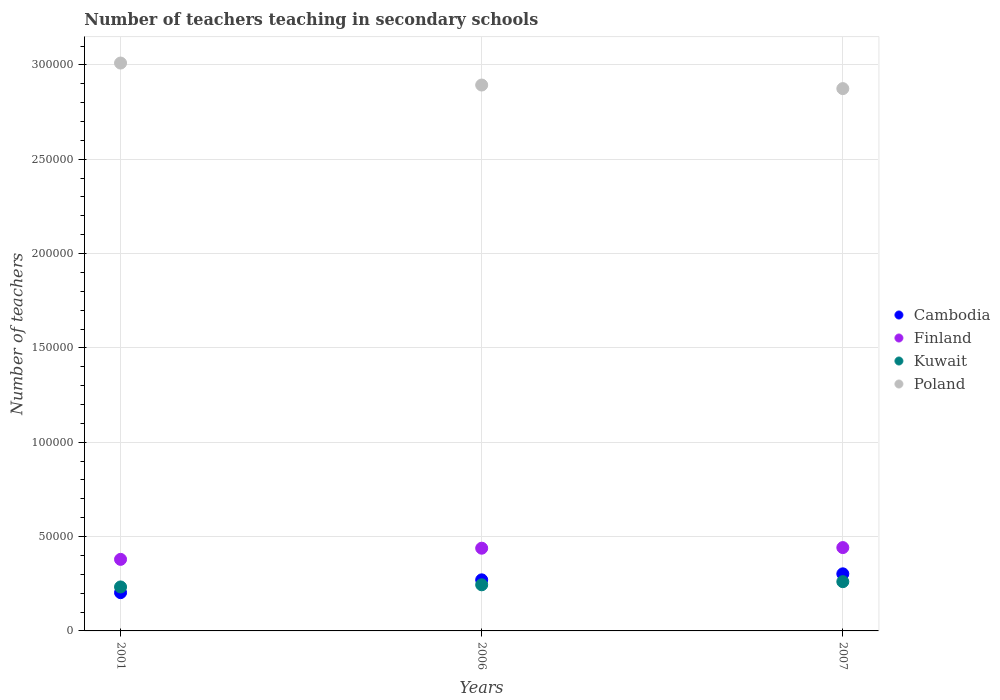What is the number of teachers teaching in secondary schools in Poland in 2007?
Give a very brief answer. 2.87e+05. Across all years, what is the maximum number of teachers teaching in secondary schools in Kuwait?
Your answer should be compact. 2.61e+04. Across all years, what is the minimum number of teachers teaching in secondary schools in Cambodia?
Provide a succinct answer. 2.03e+04. In which year was the number of teachers teaching in secondary schools in Poland maximum?
Provide a succinct answer. 2001. In which year was the number of teachers teaching in secondary schools in Finland minimum?
Offer a terse response. 2001. What is the total number of teachers teaching in secondary schools in Cambodia in the graph?
Provide a succinct answer. 7.76e+04. What is the difference between the number of teachers teaching in secondary schools in Cambodia in 2001 and that in 2007?
Provide a short and direct response. -9972. What is the difference between the number of teachers teaching in secondary schools in Poland in 2006 and the number of teachers teaching in secondary schools in Finland in 2001?
Provide a short and direct response. 2.51e+05. What is the average number of teachers teaching in secondary schools in Finland per year?
Ensure brevity in your answer.  4.20e+04. In the year 2007, what is the difference between the number of teachers teaching in secondary schools in Kuwait and number of teachers teaching in secondary schools in Finland?
Make the answer very short. -1.81e+04. In how many years, is the number of teachers teaching in secondary schools in Poland greater than 280000?
Your answer should be very brief. 3. What is the ratio of the number of teachers teaching in secondary schools in Cambodia in 2001 to that in 2006?
Your answer should be very brief. 0.75. Is the number of teachers teaching in secondary schools in Finland in 2001 less than that in 2007?
Give a very brief answer. Yes. Is the difference between the number of teachers teaching in secondary schools in Kuwait in 2001 and 2007 greater than the difference between the number of teachers teaching in secondary schools in Finland in 2001 and 2007?
Keep it short and to the point. Yes. What is the difference between the highest and the second highest number of teachers teaching in secondary schools in Kuwait?
Your answer should be compact. 1658. What is the difference between the highest and the lowest number of teachers teaching in secondary schools in Kuwait?
Your answer should be compact. 2789. In how many years, is the number of teachers teaching in secondary schools in Kuwait greater than the average number of teachers teaching in secondary schools in Kuwait taken over all years?
Keep it short and to the point. 1. How many dotlines are there?
Your answer should be compact. 4. What is the difference between two consecutive major ticks on the Y-axis?
Provide a short and direct response. 5.00e+04. Are the values on the major ticks of Y-axis written in scientific E-notation?
Make the answer very short. No. Does the graph contain any zero values?
Provide a succinct answer. No. Does the graph contain grids?
Give a very brief answer. Yes. What is the title of the graph?
Offer a terse response. Number of teachers teaching in secondary schools. Does "Faeroe Islands" appear as one of the legend labels in the graph?
Offer a very short reply. No. What is the label or title of the X-axis?
Provide a short and direct response. Years. What is the label or title of the Y-axis?
Give a very brief answer. Number of teachers. What is the Number of teachers of Cambodia in 2001?
Your answer should be compact. 2.03e+04. What is the Number of teachers in Finland in 2001?
Keep it short and to the point. 3.79e+04. What is the Number of teachers in Kuwait in 2001?
Offer a terse response. 2.33e+04. What is the Number of teachers of Poland in 2001?
Keep it short and to the point. 3.01e+05. What is the Number of teachers in Cambodia in 2006?
Your answer should be very brief. 2.71e+04. What is the Number of teachers in Finland in 2006?
Provide a short and direct response. 4.38e+04. What is the Number of teachers in Kuwait in 2006?
Offer a very short reply. 2.44e+04. What is the Number of teachers in Poland in 2006?
Provide a succinct answer. 2.89e+05. What is the Number of teachers in Cambodia in 2007?
Provide a succinct answer. 3.03e+04. What is the Number of teachers of Finland in 2007?
Your response must be concise. 4.42e+04. What is the Number of teachers in Kuwait in 2007?
Give a very brief answer. 2.61e+04. What is the Number of teachers in Poland in 2007?
Offer a very short reply. 2.87e+05. Across all years, what is the maximum Number of teachers of Cambodia?
Your answer should be compact. 3.03e+04. Across all years, what is the maximum Number of teachers of Finland?
Offer a terse response. 4.42e+04. Across all years, what is the maximum Number of teachers in Kuwait?
Your answer should be compact. 2.61e+04. Across all years, what is the maximum Number of teachers of Poland?
Offer a terse response. 3.01e+05. Across all years, what is the minimum Number of teachers in Cambodia?
Keep it short and to the point. 2.03e+04. Across all years, what is the minimum Number of teachers of Finland?
Your answer should be very brief. 3.79e+04. Across all years, what is the minimum Number of teachers in Kuwait?
Give a very brief answer. 2.33e+04. Across all years, what is the minimum Number of teachers of Poland?
Give a very brief answer. 2.87e+05. What is the total Number of teachers in Cambodia in the graph?
Offer a very short reply. 7.76e+04. What is the total Number of teachers of Finland in the graph?
Your response must be concise. 1.26e+05. What is the total Number of teachers in Kuwait in the graph?
Give a very brief answer. 7.39e+04. What is the total Number of teachers of Poland in the graph?
Your answer should be very brief. 8.78e+05. What is the difference between the Number of teachers in Cambodia in 2001 and that in 2006?
Make the answer very short. -6784. What is the difference between the Number of teachers in Finland in 2001 and that in 2006?
Keep it short and to the point. -5915. What is the difference between the Number of teachers of Kuwait in 2001 and that in 2006?
Your answer should be very brief. -1131. What is the difference between the Number of teachers of Poland in 2001 and that in 2006?
Provide a succinct answer. 1.16e+04. What is the difference between the Number of teachers in Cambodia in 2001 and that in 2007?
Provide a succinct answer. -9972. What is the difference between the Number of teachers in Finland in 2001 and that in 2007?
Provide a succinct answer. -6245. What is the difference between the Number of teachers of Kuwait in 2001 and that in 2007?
Provide a succinct answer. -2789. What is the difference between the Number of teachers of Poland in 2001 and that in 2007?
Your answer should be compact. 1.35e+04. What is the difference between the Number of teachers in Cambodia in 2006 and that in 2007?
Provide a succinct answer. -3188. What is the difference between the Number of teachers of Finland in 2006 and that in 2007?
Your answer should be very brief. -330. What is the difference between the Number of teachers of Kuwait in 2006 and that in 2007?
Ensure brevity in your answer.  -1658. What is the difference between the Number of teachers in Poland in 2006 and that in 2007?
Offer a terse response. 1899. What is the difference between the Number of teachers in Cambodia in 2001 and the Number of teachers in Finland in 2006?
Keep it short and to the point. -2.36e+04. What is the difference between the Number of teachers in Cambodia in 2001 and the Number of teachers in Kuwait in 2006?
Your answer should be very brief. -4156. What is the difference between the Number of teachers of Cambodia in 2001 and the Number of teachers of Poland in 2006?
Provide a short and direct response. -2.69e+05. What is the difference between the Number of teachers of Finland in 2001 and the Number of teachers of Kuwait in 2006?
Give a very brief answer. 1.35e+04. What is the difference between the Number of teachers of Finland in 2001 and the Number of teachers of Poland in 2006?
Provide a succinct answer. -2.51e+05. What is the difference between the Number of teachers in Kuwait in 2001 and the Number of teachers in Poland in 2006?
Offer a very short reply. -2.66e+05. What is the difference between the Number of teachers of Cambodia in 2001 and the Number of teachers of Finland in 2007?
Provide a short and direct response. -2.39e+04. What is the difference between the Number of teachers in Cambodia in 2001 and the Number of teachers in Kuwait in 2007?
Provide a succinct answer. -5814. What is the difference between the Number of teachers in Cambodia in 2001 and the Number of teachers in Poland in 2007?
Offer a very short reply. -2.67e+05. What is the difference between the Number of teachers of Finland in 2001 and the Number of teachers of Kuwait in 2007?
Give a very brief answer. 1.18e+04. What is the difference between the Number of teachers of Finland in 2001 and the Number of teachers of Poland in 2007?
Your answer should be compact. -2.50e+05. What is the difference between the Number of teachers of Kuwait in 2001 and the Number of teachers of Poland in 2007?
Provide a short and direct response. -2.64e+05. What is the difference between the Number of teachers in Cambodia in 2006 and the Number of teachers in Finland in 2007?
Keep it short and to the point. -1.71e+04. What is the difference between the Number of teachers of Cambodia in 2006 and the Number of teachers of Kuwait in 2007?
Your response must be concise. 970. What is the difference between the Number of teachers of Cambodia in 2006 and the Number of teachers of Poland in 2007?
Give a very brief answer. -2.60e+05. What is the difference between the Number of teachers in Finland in 2006 and the Number of teachers in Kuwait in 2007?
Give a very brief answer. 1.77e+04. What is the difference between the Number of teachers of Finland in 2006 and the Number of teachers of Poland in 2007?
Your answer should be very brief. -2.44e+05. What is the difference between the Number of teachers of Kuwait in 2006 and the Number of teachers of Poland in 2007?
Make the answer very short. -2.63e+05. What is the average Number of teachers of Cambodia per year?
Your response must be concise. 2.59e+04. What is the average Number of teachers in Finland per year?
Offer a terse response. 4.20e+04. What is the average Number of teachers of Kuwait per year?
Your answer should be very brief. 2.46e+04. What is the average Number of teachers of Poland per year?
Make the answer very short. 2.93e+05. In the year 2001, what is the difference between the Number of teachers of Cambodia and Number of teachers of Finland?
Give a very brief answer. -1.76e+04. In the year 2001, what is the difference between the Number of teachers of Cambodia and Number of teachers of Kuwait?
Ensure brevity in your answer.  -3025. In the year 2001, what is the difference between the Number of teachers in Cambodia and Number of teachers in Poland?
Make the answer very short. -2.81e+05. In the year 2001, what is the difference between the Number of teachers in Finland and Number of teachers in Kuwait?
Offer a terse response. 1.46e+04. In the year 2001, what is the difference between the Number of teachers in Finland and Number of teachers in Poland?
Your response must be concise. -2.63e+05. In the year 2001, what is the difference between the Number of teachers of Kuwait and Number of teachers of Poland?
Ensure brevity in your answer.  -2.78e+05. In the year 2006, what is the difference between the Number of teachers of Cambodia and Number of teachers of Finland?
Your answer should be very brief. -1.68e+04. In the year 2006, what is the difference between the Number of teachers of Cambodia and Number of teachers of Kuwait?
Your answer should be compact. 2628. In the year 2006, what is the difference between the Number of teachers in Cambodia and Number of teachers in Poland?
Make the answer very short. -2.62e+05. In the year 2006, what is the difference between the Number of teachers in Finland and Number of teachers in Kuwait?
Provide a succinct answer. 1.94e+04. In the year 2006, what is the difference between the Number of teachers in Finland and Number of teachers in Poland?
Your answer should be compact. -2.45e+05. In the year 2006, what is the difference between the Number of teachers in Kuwait and Number of teachers in Poland?
Your response must be concise. -2.65e+05. In the year 2007, what is the difference between the Number of teachers of Cambodia and Number of teachers of Finland?
Your answer should be very brief. -1.39e+04. In the year 2007, what is the difference between the Number of teachers in Cambodia and Number of teachers in Kuwait?
Make the answer very short. 4158. In the year 2007, what is the difference between the Number of teachers of Cambodia and Number of teachers of Poland?
Your response must be concise. -2.57e+05. In the year 2007, what is the difference between the Number of teachers in Finland and Number of teachers in Kuwait?
Provide a short and direct response. 1.81e+04. In the year 2007, what is the difference between the Number of teachers of Finland and Number of teachers of Poland?
Provide a succinct answer. -2.43e+05. In the year 2007, what is the difference between the Number of teachers in Kuwait and Number of teachers in Poland?
Keep it short and to the point. -2.61e+05. What is the ratio of the Number of teachers in Cambodia in 2001 to that in 2006?
Make the answer very short. 0.75. What is the ratio of the Number of teachers of Finland in 2001 to that in 2006?
Make the answer very short. 0.87. What is the ratio of the Number of teachers of Kuwait in 2001 to that in 2006?
Offer a terse response. 0.95. What is the ratio of the Number of teachers of Poland in 2001 to that in 2006?
Your answer should be very brief. 1.04. What is the ratio of the Number of teachers in Cambodia in 2001 to that in 2007?
Ensure brevity in your answer.  0.67. What is the ratio of the Number of teachers of Finland in 2001 to that in 2007?
Your answer should be compact. 0.86. What is the ratio of the Number of teachers of Kuwait in 2001 to that in 2007?
Give a very brief answer. 0.89. What is the ratio of the Number of teachers of Poland in 2001 to that in 2007?
Give a very brief answer. 1.05. What is the ratio of the Number of teachers in Cambodia in 2006 to that in 2007?
Your answer should be compact. 0.89. What is the ratio of the Number of teachers in Kuwait in 2006 to that in 2007?
Provide a short and direct response. 0.94. What is the ratio of the Number of teachers in Poland in 2006 to that in 2007?
Offer a very short reply. 1.01. What is the difference between the highest and the second highest Number of teachers of Cambodia?
Give a very brief answer. 3188. What is the difference between the highest and the second highest Number of teachers of Finland?
Your response must be concise. 330. What is the difference between the highest and the second highest Number of teachers in Kuwait?
Your answer should be very brief. 1658. What is the difference between the highest and the second highest Number of teachers of Poland?
Give a very brief answer. 1.16e+04. What is the difference between the highest and the lowest Number of teachers of Cambodia?
Provide a short and direct response. 9972. What is the difference between the highest and the lowest Number of teachers of Finland?
Offer a terse response. 6245. What is the difference between the highest and the lowest Number of teachers in Kuwait?
Provide a short and direct response. 2789. What is the difference between the highest and the lowest Number of teachers in Poland?
Your answer should be very brief. 1.35e+04. 